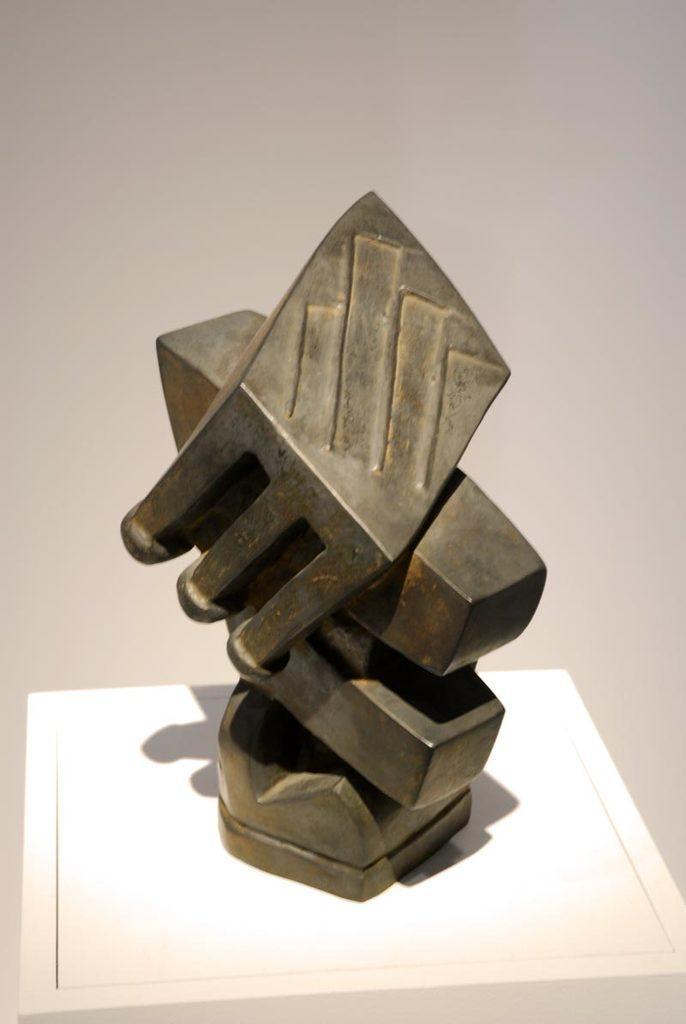Could you give a brief overview of what you see in this image? At the bottom of the image we can see a table, on the table we can see a metal object. Behind the metal object we can see a wall. 